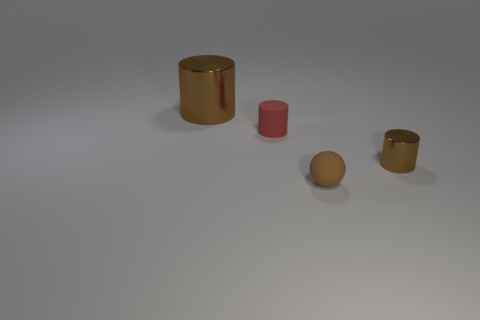Subtract all tiny cylinders. How many cylinders are left? 1 Add 2 large red cylinders. How many objects exist? 6 Subtract all spheres. How many objects are left? 3 Subtract all red cylinders. How many cylinders are left? 2 Add 1 tiny cylinders. How many tiny cylinders are left? 3 Add 2 cyan matte cubes. How many cyan matte cubes exist? 2 Subtract 0 gray balls. How many objects are left? 4 Subtract 1 balls. How many balls are left? 0 Subtract all green cylinders. Subtract all purple balls. How many cylinders are left? 3 Subtract all brown spheres. How many blue cylinders are left? 0 